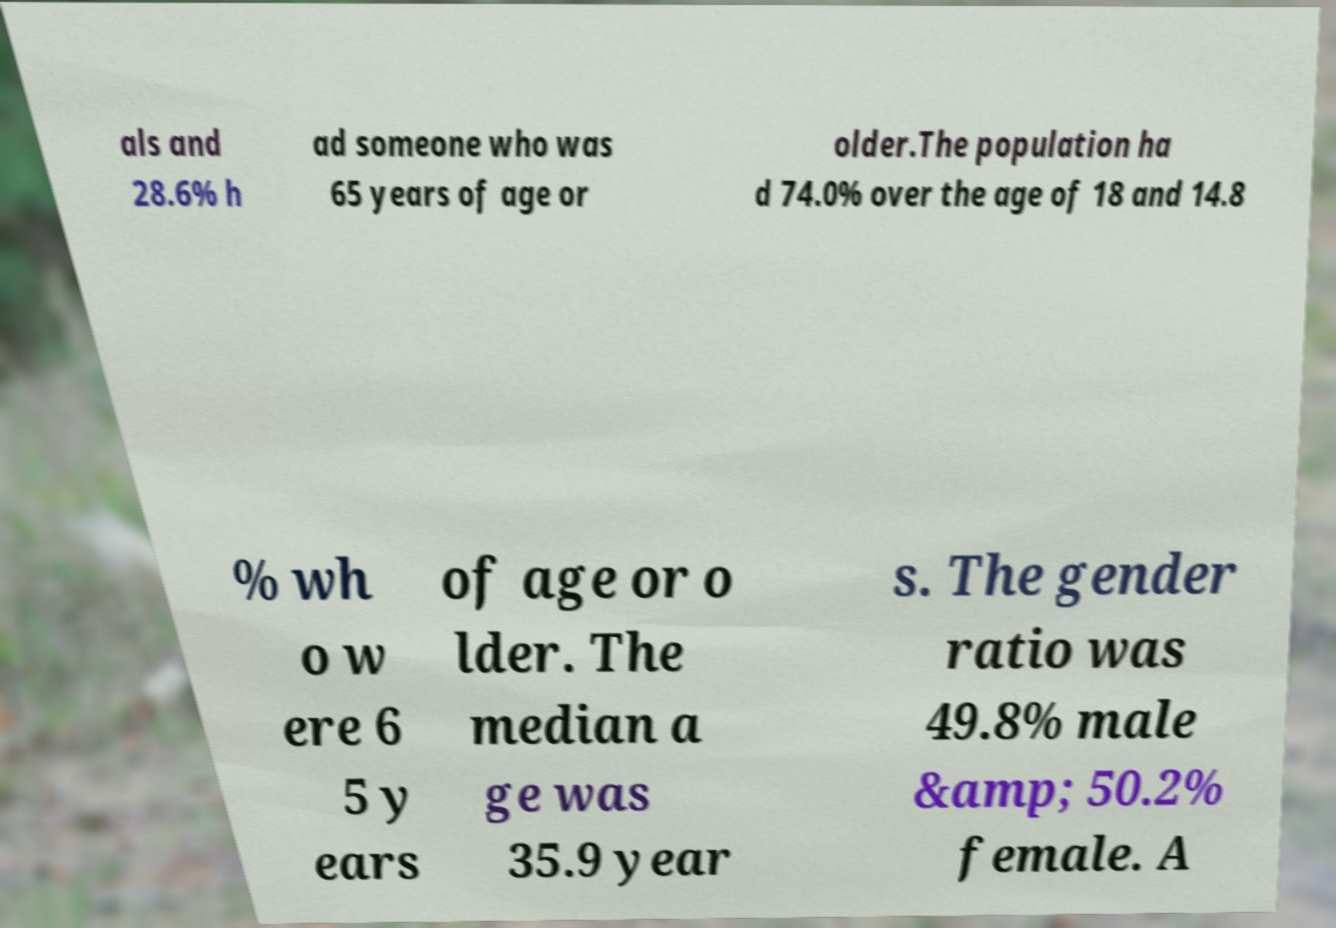Please identify and transcribe the text found in this image. als and 28.6% h ad someone who was 65 years of age or older.The population ha d 74.0% over the age of 18 and 14.8 % wh o w ere 6 5 y ears of age or o lder. The median a ge was 35.9 year s. The gender ratio was 49.8% male &amp; 50.2% female. A 